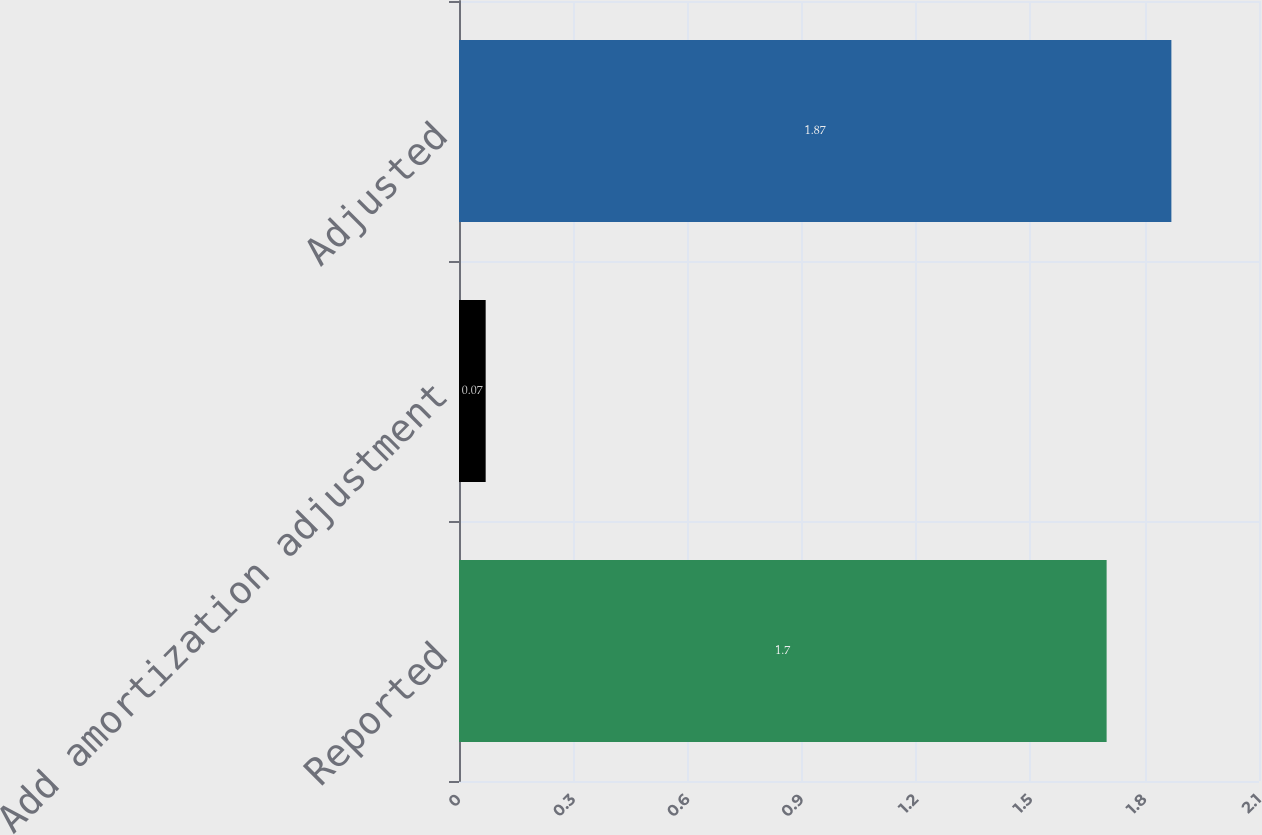Convert chart. <chart><loc_0><loc_0><loc_500><loc_500><bar_chart><fcel>Reported<fcel>Add amortization adjustment<fcel>Adjusted<nl><fcel>1.7<fcel>0.07<fcel>1.87<nl></chart> 